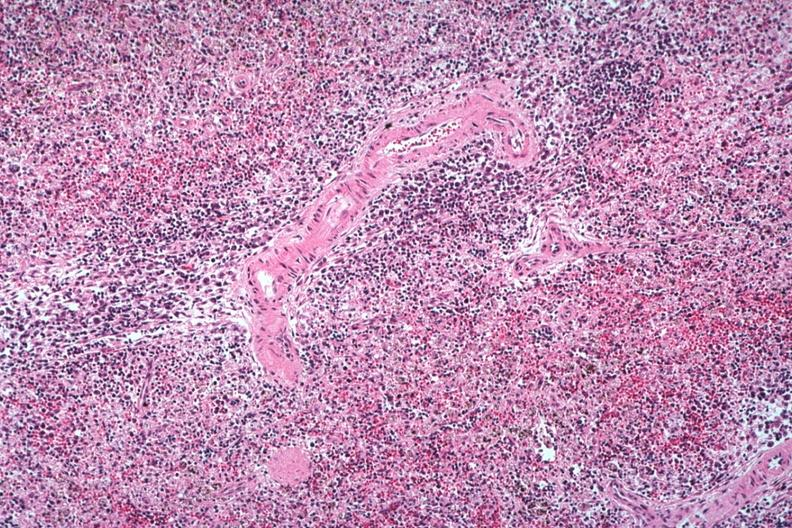what does this image show?
Answer the question using a single word or phrase. Well seen atypical cells surrounding splenic arteriole man probably died of viral pneumonia likely to have been influenzae 